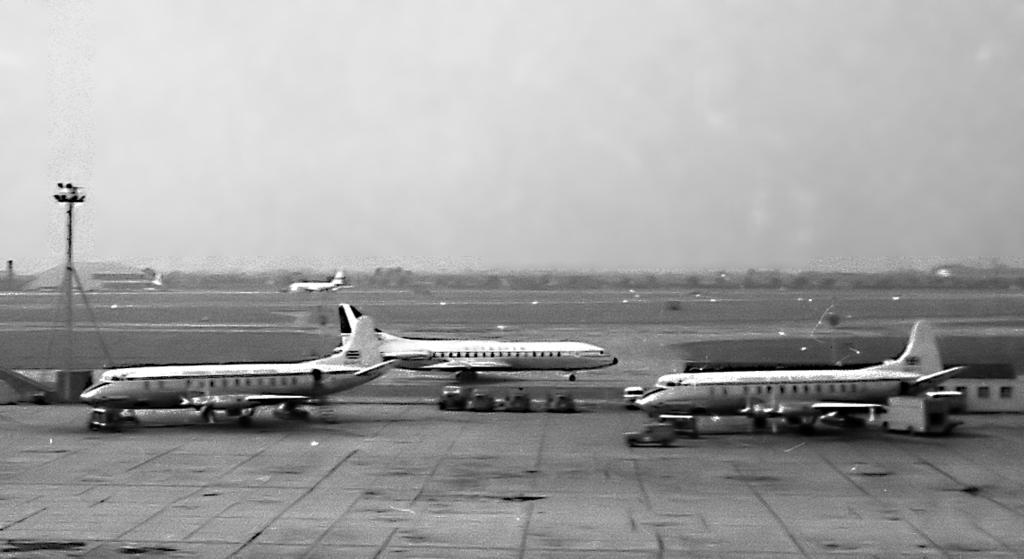How many airplanes are on the runway in the image? There are four airplanes on the runway in the image. What other types of vehicles can be seen in the image? There are vehicles in the image, but the specific types are not mentioned. What is the tall, thin object in the image? There is: There is a pole in the image. What are the sources of illumination in the image? There are lights in the image. What type of vegetation is present in the image? There are trees in the image. What type of structures are visible in the image? There are buildings in the image. What can be seen in the sky in the image? The sky is visible in the image. How many degrees does the zebra have in the image? There is no zebra present in the image, so it is not possible to determine its degree. 